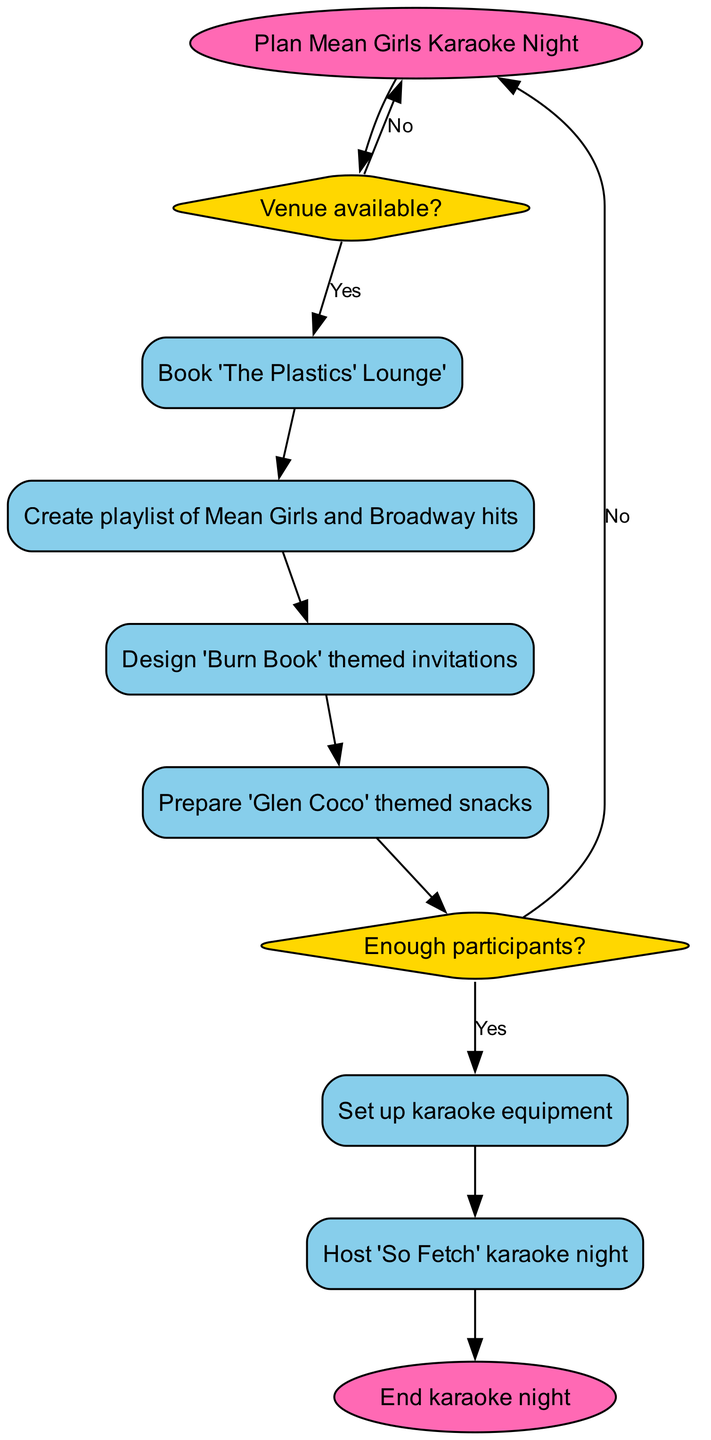What is the first step in organizing the karaoke night? The first step in the flowchart is "Plan Mean Girls Karaoke Night," which is the start node where the process begins.
Answer: Plan Mean Girls Karaoke Night How many decision points are in the flowchart? There are two decision points in the flowchart, which ask about venue availability and the number of participants.
Answer: 2 What happens if the venue is not available? If the venue is not available, the flowchart indicates to go back to "Plan Mean Girls Karaoke Night" to reconsider the planning.
Answer: Plan Mean Girls Karaoke Night What is the final action in the karaoke night flowchart? The final action in the flowchart is "End karaoke night," which signifies the closing step of the process.
Answer: End karaoke night Which snack is specifically mentioned for the karaoke night? The snack mentioned in the flowchart is "'Glen Coco' themed snacks," part of the preparation steps for the event.
Answer: 'Glen Coco' themed snacks If there are not enough participants, what is the next step? If there are not enough participants, the flowchart directs to go back to "Plan Mean Girls Karaoke Night," indicating that the event should be reconsidered.
Answer: Plan Mean Girls Karaoke Night What is done after creating the playlist? After creating the playlist of Mean Girls and Broadway hits, the next step is to design "Burn Book" themed invitations based on the flowchart's connection sequence.
Answer: Design 'Burn Book' themed invitations How many processes are listed in the flowchart? There are five processes listed in the flowchart, including booking the lounge, creating a playlist, designing invitations, preparing snacks, and setting up karaoke equipment.
Answer: 5 